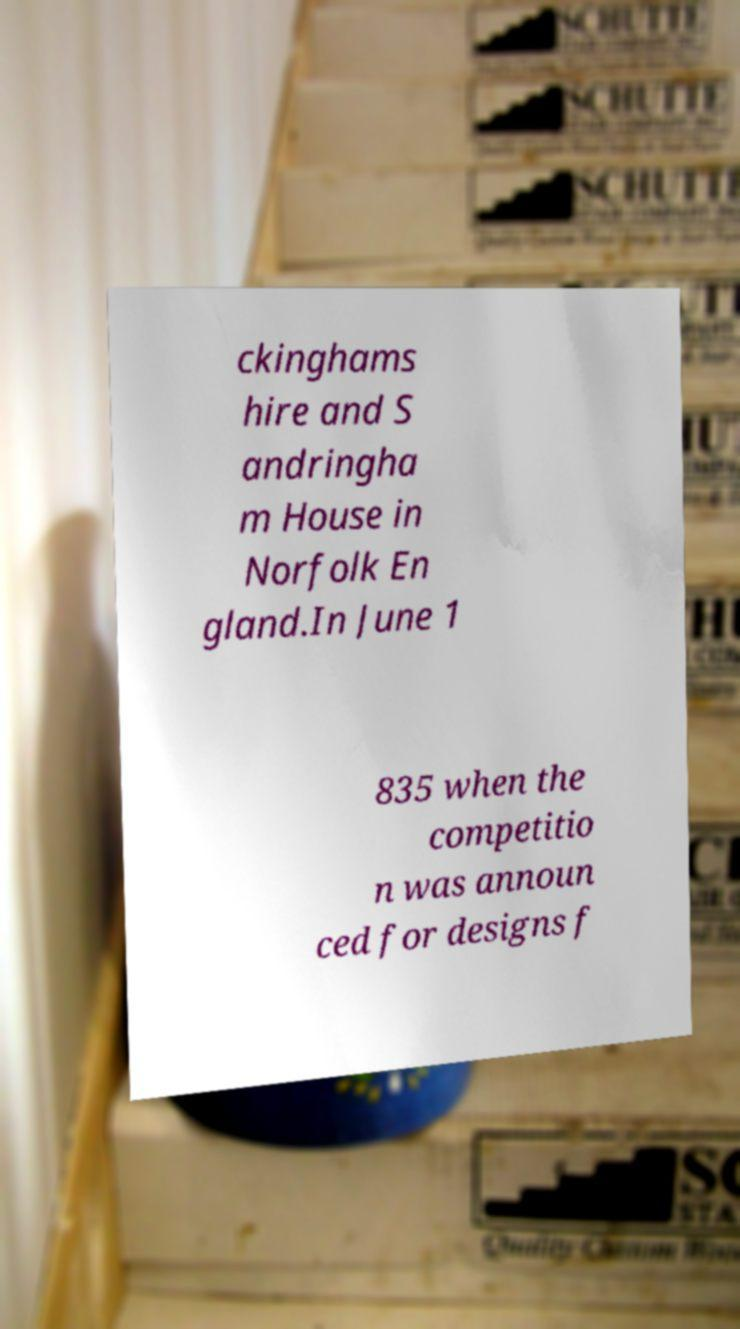What messages or text are displayed in this image? I need them in a readable, typed format. ckinghams hire and S andringha m House in Norfolk En gland.In June 1 835 when the competitio n was announ ced for designs f 